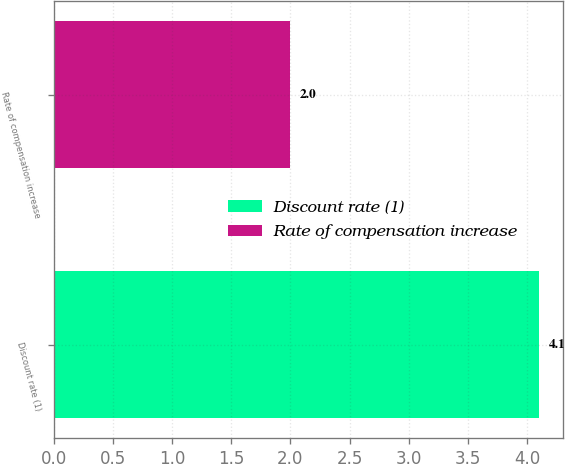Convert chart. <chart><loc_0><loc_0><loc_500><loc_500><bar_chart><fcel>Discount rate (1)<fcel>Rate of compensation increase<nl><fcel>4.1<fcel>2<nl></chart> 